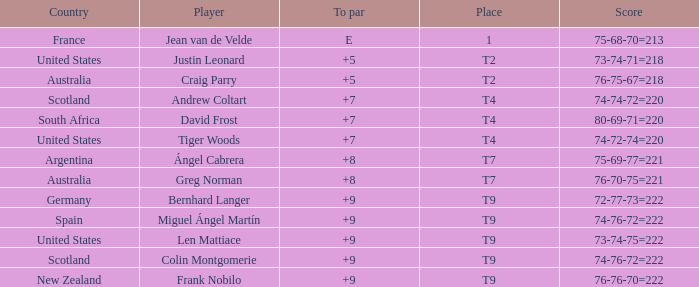What is the place number for the player with a To Par score of 'E'? 1.0. 